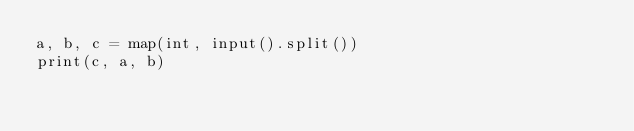<code> <loc_0><loc_0><loc_500><loc_500><_Python_>a, b, c = map(int, input().split())
print(c, a, b)</code> 